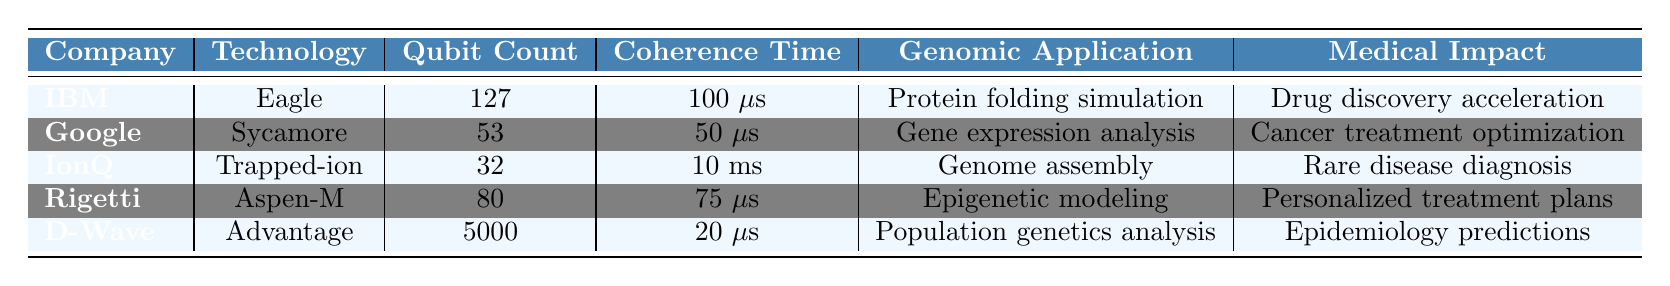What is the qubit count of the technology developed by IBM? The qubit count of IBM's technology, Eagle, is explicitly stated in the table as 127.
Answer: 127 Which company's technology has the longest coherence time? By comparing the coherence times listed for each company, IBM's Eagle has a coherence time of 100 microseconds, which is the longest among the listed technologies.
Answer: IBM How many technologies have a qubit count greater than 80? The technologies with qubit counts greater than 80 are Eagle (127) and Advantage (5000). Therefore, there are 2 such technologies.
Answer: 2 Is the quantum technology from Google used for protein folding simulation? Google’s technology, Sycamore, is specifically stated to be used for gene expression analysis, not protein folding simulation. Therefore, the statement is false.
Answer: No What is the average coherence time of the technologies listed in the table? The coherence times are 100 microseconds (IBM), 50 microseconds (Google), 10 milliseconds (IonQ), 75 microseconds (Rigetti), and 20 microseconds (D-Wave). Converting 10 milliseconds to microseconds gives 10,000 microseconds. The average is calculated as (100 + 50 + 10,000 + 75 + 20) / 5 = 2,245 microseconds.
Answer: 2245 microseconds Which genomic application corresponds to the technology with the highest qubit count? D-Wave's technology, Advantage, has the highest qubit count of 5000, and its genomic application is population genetics analysis.
Answer: Population genetics analysis What is the medical impact of IonQ's technology? The table lists the medical impact of IonQ's Trapped-ion technology as rare disease diagnosis.
Answer: Rare disease diagnosis If we consider only the technologies with coherence times longer than 50 microseconds, which company has a technology with the highest qubit count? Among the technologies with coherence times longer than 50 microseconds, Eagle (IBM) has 127 qubits, and Advantage (D-Wave) has 5000 qubits, which is the highest.
Answer: D-Wave Which genomic application related to cancer treatment optimization has the lowest qubit count? The technology related to cancer treatment optimization is Google's Sycamore with a qubit count of 53, which is lower than any other listed technology used for genomic applications.
Answer: 53 